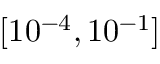Convert formula to latex. <formula><loc_0><loc_0><loc_500><loc_500>[ 1 0 ^ { - 4 } , 1 0 ^ { - 1 } ]</formula> 